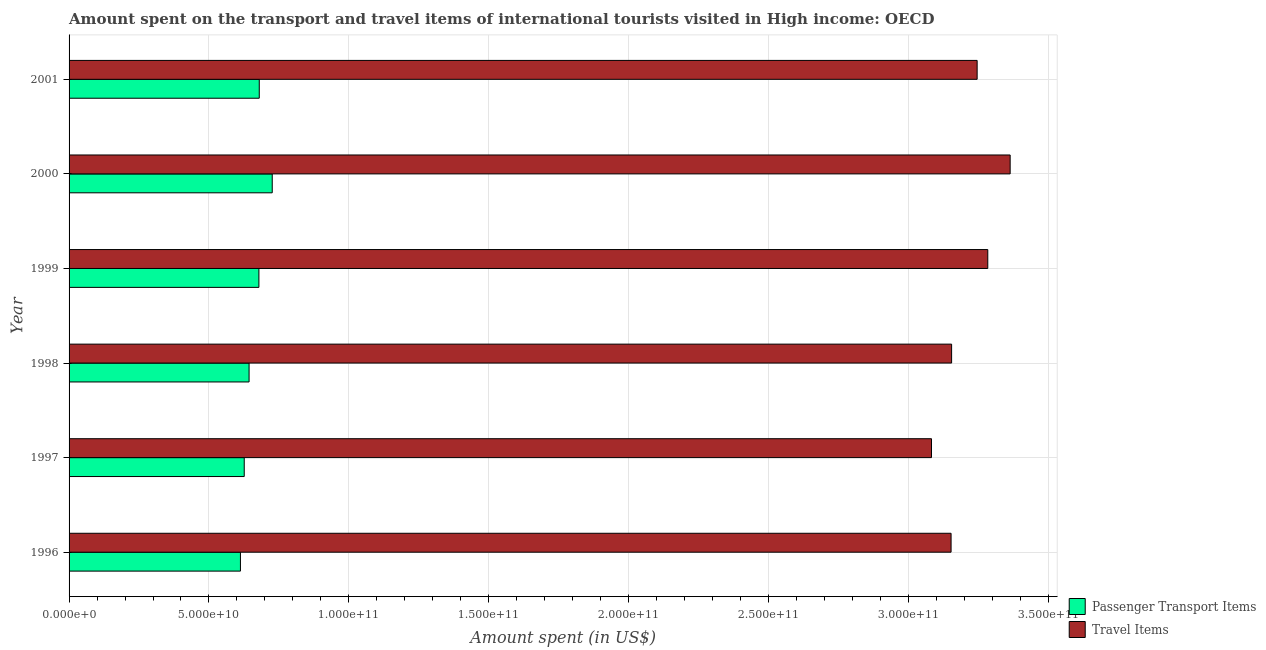How many different coloured bars are there?
Keep it short and to the point. 2. How many groups of bars are there?
Make the answer very short. 6. Are the number of bars per tick equal to the number of legend labels?
Your answer should be very brief. Yes. Are the number of bars on each tick of the Y-axis equal?
Your answer should be compact. Yes. What is the label of the 5th group of bars from the top?
Your answer should be very brief. 1997. What is the amount spent in travel items in 2001?
Provide a succinct answer. 3.25e+11. Across all years, what is the maximum amount spent in travel items?
Your response must be concise. 3.36e+11. Across all years, what is the minimum amount spent in travel items?
Your answer should be compact. 3.08e+11. In which year was the amount spent on passenger transport items maximum?
Your answer should be very brief. 2000. What is the total amount spent on passenger transport items in the graph?
Give a very brief answer. 3.97e+11. What is the difference between the amount spent in travel items in 1997 and that in 2001?
Keep it short and to the point. -1.63e+1. What is the difference between the amount spent in travel items in 1999 and the amount spent on passenger transport items in 1998?
Your response must be concise. 2.64e+11. What is the average amount spent on passenger transport items per year?
Keep it short and to the point. 6.61e+1. In the year 1998, what is the difference between the amount spent on passenger transport items and amount spent in travel items?
Keep it short and to the point. -2.51e+11. In how many years, is the amount spent in travel items greater than 100000000000 US$?
Offer a terse response. 6. What is the ratio of the amount spent in travel items in 1996 to that in 2000?
Your response must be concise. 0.94. Is the difference between the amount spent on passenger transport items in 1996 and 1999 greater than the difference between the amount spent in travel items in 1996 and 1999?
Provide a succinct answer. Yes. What is the difference between the highest and the second highest amount spent on passenger transport items?
Your answer should be compact. 4.64e+09. What is the difference between the highest and the lowest amount spent in travel items?
Keep it short and to the point. 2.81e+1. What does the 2nd bar from the top in 2001 represents?
Make the answer very short. Passenger Transport Items. What does the 1st bar from the bottom in 1996 represents?
Provide a short and direct response. Passenger Transport Items. Are all the bars in the graph horizontal?
Your response must be concise. Yes. How many years are there in the graph?
Your response must be concise. 6. Does the graph contain any zero values?
Make the answer very short. No. Where does the legend appear in the graph?
Provide a succinct answer. Bottom right. How many legend labels are there?
Offer a terse response. 2. What is the title of the graph?
Your answer should be very brief. Amount spent on the transport and travel items of international tourists visited in High income: OECD. Does "International Visitors" appear as one of the legend labels in the graph?
Provide a succinct answer. No. What is the label or title of the X-axis?
Your response must be concise. Amount spent (in US$). What is the Amount spent (in US$) of Passenger Transport Items in 1996?
Provide a succinct answer. 6.12e+1. What is the Amount spent (in US$) of Travel Items in 1996?
Keep it short and to the point. 3.15e+11. What is the Amount spent (in US$) of Passenger Transport Items in 1997?
Offer a terse response. 6.26e+1. What is the Amount spent (in US$) of Travel Items in 1997?
Your response must be concise. 3.08e+11. What is the Amount spent (in US$) in Passenger Transport Items in 1998?
Give a very brief answer. 6.43e+1. What is the Amount spent (in US$) in Travel Items in 1998?
Your response must be concise. 3.15e+11. What is the Amount spent (in US$) of Passenger Transport Items in 1999?
Keep it short and to the point. 6.79e+1. What is the Amount spent (in US$) in Travel Items in 1999?
Provide a succinct answer. 3.28e+11. What is the Amount spent (in US$) of Passenger Transport Items in 2000?
Offer a terse response. 7.26e+1. What is the Amount spent (in US$) of Travel Items in 2000?
Ensure brevity in your answer.  3.36e+11. What is the Amount spent (in US$) of Passenger Transport Items in 2001?
Offer a very short reply. 6.80e+1. What is the Amount spent (in US$) in Travel Items in 2001?
Make the answer very short. 3.25e+11. Across all years, what is the maximum Amount spent (in US$) in Passenger Transport Items?
Your response must be concise. 7.26e+1. Across all years, what is the maximum Amount spent (in US$) of Travel Items?
Give a very brief answer. 3.36e+11. Across all years, what is the minimum Amount spent (in US$) of Passenger Transport Items?
Provide a succinct answer. 6.12e+1. Across all years, what is the minimum Amount spent (in US$) in Travel Items?
Provide a short and direct response. 3.08e+11. What is the total Amount spent (in US$) of Passenger Transport Items in the graph?
Provide a succinct answer. 3.97e+11. What is the total Amount spent (in US$) in Travel Items in the graph?
Provide a succinct answer. 1.93e+12. What is the difference between the Amount spent (in US$) in Passenger Transport Items in 1996 and that in 1997?
Ensure brevity in your answer.  -1.36e+09. What is the difference between the Amount spent (in US$) of Travel Items in 1996 and that in 1997?
Make the answer very short. 7.00e+09. What is the difference between the Amount spent (in US$) in Passenger Transport Items in 1996 and that in 1998?
Provide a short and direct response. -3.09e+09. What is the difference between the Amount spent (in US$) in Travel Items in 1996 and that in 1998?
Your answer should be very brief. -1.87e+08. What is the difference between the Amount spent (in US$) of Passenger Transport Items in 1996 and that in 1999?
Make the answer very short. -6.61e+09. What is the difference between the Amount spent (in US$) of Travel Items in 1996 and that in 1999?
Make the answer very short. -1.31e+1. What is the difference between the Amount spent (in US$) of Passenger Transport Items in 1996 and that in 2000?
Your answer should be very brief. -1.14e+1. What is the difference between the Amount spent (in US$) in Travel Items in 1996 and that in 2000?
Your response must be concise. -2.11e+1. What is the difference between the Amount spent (in US$) in Passenger Transport Items in 1996 and that in 2001?
Provide a short and direct response. -6.73e+09. What is the difference between the Amount spent (in US$) in Travel Items in 1996 and that in 2001?
Offer a terse response. -9.32e+09. What is the difference between the Amount spent (in US$) in Passenger Transport Items in 1997 and that in 1998?
Offer a terse response. -1.73e+09. What is the difference between the Amount spent (in US$) of Travel Items in 1997 and that in 1998?
Ensure brevity in your answer.  -7.18e+09. What is the difference between the Amount spent (in US$) in Passenger Transport Items in 1997 and that in 1999?
Your answer should be very brief. -5.24e+09. What is the difference between the Amount spent (in US$) in Travel Items in 1997 and that in 1999?
Your response must be concise. -2.01e+1. What is the difference between the Amount spent (in US$) of Passenger Transport Items in 1997 and that in 2000?
Your response must be concise. -1.00e+1. What is the difference between the Amount spent (in US$) in Travel Items in 1997 and that in 2000?
Make the answer very short. -2.81e+1. What is the difference between the Amount spent (in US$) of Passenger Transport Items in 1997 and that in 2001?
Make the answer very short. -5.37e+09. What is the difference between the Amount spent (in US$) in Travel Items in 1997 and that in 2001?
Your answer should be compact. -1.63e+1. What is the difference between the Amount spent (in US$) in Passenger Transport Items in 1998 and that in 1999?
Give a very brief answer. -3.52e+09. What is the difference between the Amount spent (in US$) in Travel Items in 1998 and that in 1999?
Keep it short and to the point. -1.29e+1. What is the difference between the Amount spent (in US$) of Passenger Transport Items in 1998 and that in 2000?
Make the answer very short. -8.28e+09. What is the difference between the Amount spent (in US$) of Travel Items in 1998 and that in 2000?
Give a very brief answer. -2.09e+1. What is the difference between the Amount spent (in US$) of Passenger Transport Items in 1998 and that in 2001?
Keep it short and to the point. -3.64e+09. What is the difference between the Amount spent (in US$) in Travel Items in 1998 and that in 2001?
Your answer should be very brief. -9.13e+09. What is the difference between the Amount spent (in US$) of Passenger Transport Items in 1999 and that in 2000?
Keep it short and to the point. -4.76e+09. What is the difference between the Amount spent (in US$) in Travel Items in 1999 and that in 2000?
Keep it short and to the point. -8.00e+09. What is the difference between the Amount spent (in US$) of Passenger Transport Items in 1999 and that in 2001?
Keep it short and to the point. -1.26e+08. What is the difference between the Amount spent (in US$) of Travel Items in 1999 and that in 2001?
Your answer should be compact. 3.80e+09. What is the difference between the Amount spent (in US$) of Passenger Transport Items in 2000 and that in 2001?
Give a very brief answer. 4.64e+09. What is the difference between the Amount spent (in US$) of Travel Items in 2000 and that in 2001?
Your answer should be compact. 1.18e+1. What is the difference between the Amount spent (in US$) in Passenger Transport Items in 1996 and the Amount spent (in US$) in Travel Items in 1997?
Your response must be concise. -2.47e+11. What is the difference between the Amount spent (in US$) in Passenger Transport Items in 1996 and the Amount spent (in US$) in Travel Items in 1998?
Your answer should be very brief. -2.54e+11. What is the difference between the Amount spent (in US$) of Passenger Transport Items in 1996 and the Amount spent (in US$) of Travel Items in 1999?
Your answer should be compact. -2.67e+11. What is the difference between the Amount spent (in US$) in Passenger Transport Items in 1996 and the Amount spent (in US$) in Travel Items in 2000?
Your response must be concise. -2.75e+11. What is the difference between the Amount spent (in US$) in Passenger Transport Items in 1996 and the Amount spent (in US$) in Travel Items in 2001?
Give a very brief answer. -2.63e+11. What is the difference between the Amount spent (in US$) in Passenger Transport Items in 1997 and the Amount spent (in US$) in Travel Items in 1998?
Your answer should be compact. -2.53e+11. What is the difference between the Amount spent (in US$) in Passenger Transport Items in 1997 and the Amount spent (in US$) in Travel Items in 1999?
Offer a very short reply. -2.66e+11. What is the difference between the Amount spent (in US$) in Passenger Transport Items in 1997 and the Amount spent (in US$) in Travel Items in 2000?
Your answer should be compact. -2.74e+11. What is the difference between the Amount spent (in US$) of Passenger Transport Items in 1997 and the Amount spent (in US$) of Travel Items in 2001?
Offer a terse response. -2.62e+11. What is the difference between the Amount spent (in US$) of Passenger Transport Items in 1998 and the Amount spent (in US$) of Travel Items in 1999?
Provide a short and direct response. -2.64e+11. What is the difference between the Amount spent (in US$) of Passenger Transport Items in 1998 and the Amount spent (in US$) of Travel Items in 2000?
Provide a succinct answer. -2.72e+11. What is the difference between the Amount spent (in US$) of Passenger Transport Items in 1998 and the Amount spent (in US$) of Travel Items in 2001?
Provide a short and direct response. -2.60e+11. What is the difference between the Amount spent (in US$) of Passenger Transport Items in 1999 and the Amount spent (in US$) of Travel Items in 2000?
Offer a very short reply. -2.69e+11. What is the difference between the Amount spent (in US$) in Passenger Transport Items in 1999 and the Amount spent (in US$) in Travel Items in 2001?
Provide a short and direct response. -2.57e+11. What is the difference between the Amount spent (in US$) in Passenger Transport Items in 2000 and the Amount spent (in US$) in Travel Items in 2001?
Make the answer very short. -2.52e+11. What is the average Amount spent (in US$) of Passenger Transport Items per year?
Provide a succinct answer. 6.61e+1. What is the average Amount spent (in US$) of Travel Items per year?
Make the answer very short. 3.21e+11. In the year 1996, what is the difference between the Amount spent (in US$) in Passenger Transport Items and Amount spent (in US$) in Travel Items?
Offer a terse response. -2.54e+11. In the year 1997, what is the difference between the Amount spent (in US$) of Passenger Transport Items and Amount spent (in US$) of Travel Items?
Your answer should be compact. -2.46e+11. In the year 1998, what is the difference between the Amount spent (in US$) in Passenger Transport Items and Amount spent (in US$) in Travel Items?
Offer a very short reply. -2.51e+11. In the year 1999, what is the difference between the Amount spent (in US$) in Passenger Transport Items and Amount spent (in US$) in Travel Items?
Make the answer very short. -2.61e+11. In the year 2000, what is the difference between the Amount spent (in US$) of Passenger Transport Items and Amount spent (in US$) of Travel Items?
Provide a short and direct response. -2.64e+11. In the year 2001, what is the difference between the Amount spent (in US$) in Passenger Transport Items and Amount spent (in US$) in Travel Items?
Keep it short and to the point. -2.57e+11. What is the ratio of the Amount spent (in US$) in Passenger Transport Items in 1996 to that in 1997?
Your answer should be compact. 0.98. What is the ratio of the Amount spent (in US$) in Travel Items in 1996 to that in 1997?
Give a very brief answer. 1.02. What is the ratio of the Amount spent (in US$) in Passenger Transport Items in 1996 to that in 1999?
Give a very brief answer. 0.9. What is the ratio of the Amount spent (in US$) of Passenger Transport Items in 1996 to that in 2000?
Ensure brevity in your answer.  0.84. What is the ratio of the Amount spent (in US$) of Travel Items in 1996 to that in 2000?
Offer a terse response. 0.94. What is the ratio of the Amount spent (in US$) in Passenger Transport Items in 1996 to that in 2001?
Your answer should be very brief. 0.9. What is the ratio of the Amount spent (in US$) in Travel Items in 1996 to that in 2001?
Your response must be concise. 0.97. What is the ratio of the Amount spent (in US$) in Passenger Transport Items in 1997 to that in 1998?
Make the answer very short. 0.97. What is the ratio of the Amount spent (in US$) of Travel Items in 1997 to that in 1998?
Your answer should be very brief. 0.98. What is the ratio of the Amount spent (in US$) in Passenger Transport Items in 1997 to that in 1999?
Give a very brief answer. 0.92. What is the ratio of the Amount spent (in US$) in Travel Items in 1997 to that in 1999?
Make the answer very short. 0.94. What is the ratio of the Amount spent (in US$) of Passenger Transport Items in 1997 to that in 2000?
Provide a short and direct response. 0.86. What is the ratio of the Amount spent (in US$) in Travel Items in 1997 to that in 2000?
Offer a very short reply. 0.92. What is the ratio of the Amount spent (in US$) in Passenger Transport Items in 1997 to that in 2001?
Provide a succinct answer. 0.92. What is the ratio of the Amount spent (in US$) of Travel Items in 1997 to that in 2001?
Give a very brief answer. 0.95. What is the ratio of the Amount spent (in US$) in Passenger Transport Items in 1998 to that in 1999?
Your answer should be very brief. 0.95. What is the ratio of the Amount spent (in US$) of Travel Items in 1998 to that in 1999?
Your response must be concise. 0.96. What is the ratio of the Amount spent (in US$) of Passenger Transport Items in 1998 to that in 2000?
Offer a terse response. 0.89. What is the ratio of the Amount spent (in US$) in Travel Items in 1998 to that in 2000?
Offer a very short reply. 0.94. What is the ratio of the Amount spent (in US$) of Passenger Transport Items in 1998 to that in 2001?
Your answer should be very brief. 0.95. What is the ratio of the Amount spent (in US$) in Travel Items in 1998 to that in 2001?
Keep it short and to the point. 0.97. What is the ratio of the Amount spent (in US$) in Passenger Transport Items in 1999 to that in 2000?
Provide a succinct answer. 0.93. What is the ratio of the Amount spent (in US$) of Travel Items in 1999 to that in 2000?
Provide a succinct answer. 0.98. What is the ratio of the Amount spent (in US$) of Passenger Transport Items in 1999 to that in 2001?
Keep it short and to the point. 1. What is the ratio of the Amount spent (in US$) in Travel Items in 1999 to that in 2001?
Provide a succinct answer. 1.01. What is the ratio of the Amount spent (in US$) of Passenger Transport Items in 2000 to that in 2001?
Provide a short and direct response. 1.07. What is the ratio of the Amount spent (in US$) in Travel Items in 2000 to that in 2001?
Your answer should be very brief. 1.04. What is the difference between the highest and the second highest Amount spent (in US$) of Passenger Transport Items?
Give a very brief answer. 4.64e+09. What is the difference between the highest and the second highest Amount spent (in US$) of Travel Items?
Offer a terse response. 8.00e+09. What is the difference between the highest and the lowest Amount spent (in US$) in Passenger Transport Items?
Make the answer very short. 1.14e+1. What is the difference between the highest and the lowest Amount spent (in US$) of Travel Items?
Your answer should be compact. 2.81e+1. 